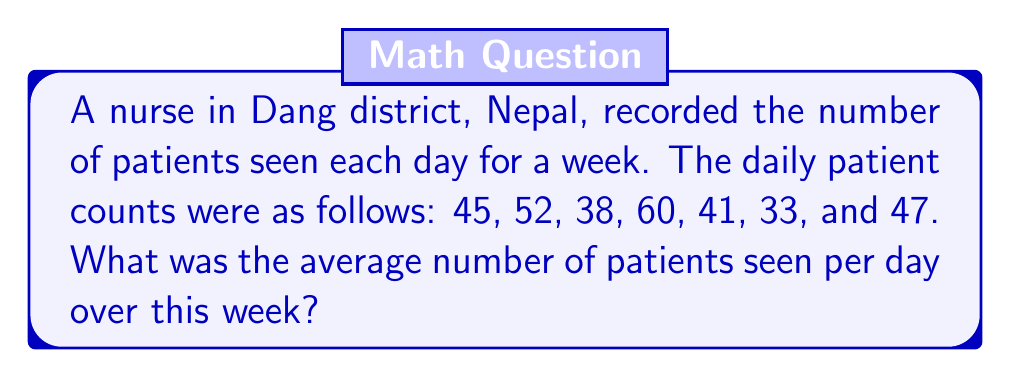Show me your answer to this math problem. To calculate the average number of patients seen per day, we need to:

1. Sum up the total number of patients seen over the week
2. Divide this sum by the number of days (7)

Let's break it down step-by-step:

1. Sum of patients:
   $$ 45 + 52 + 38 + 60 + 41 + 33 + 47 = 316 $$

2. Calculate the average:
   $$ \text{Average} = \frac{\text{Sum of patients}}{\text{Number of days}} $$
   $$ \text{Average} = \frac{316}{7} = 45.1428571... $$

3. Round to two decimal places:
   $$ \text{Average} \approx 45.14 $$

Therefore, the average number of patients seen per day over the week was approximately 45.14 patients.
Answer: 45.14 patients per day 